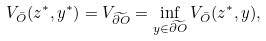<formula> <loc_0><loc_0><loc_500><loc_500>V _ { \bar { O } } ( z ^ { * } , y ^ { * } ) = V _ { \widetilde { \partial O } } = \inf _ { y \in \widetilde { \partial O } } V _ { \bar { O } } ( z ^ { * } , y ) ,</formula> 